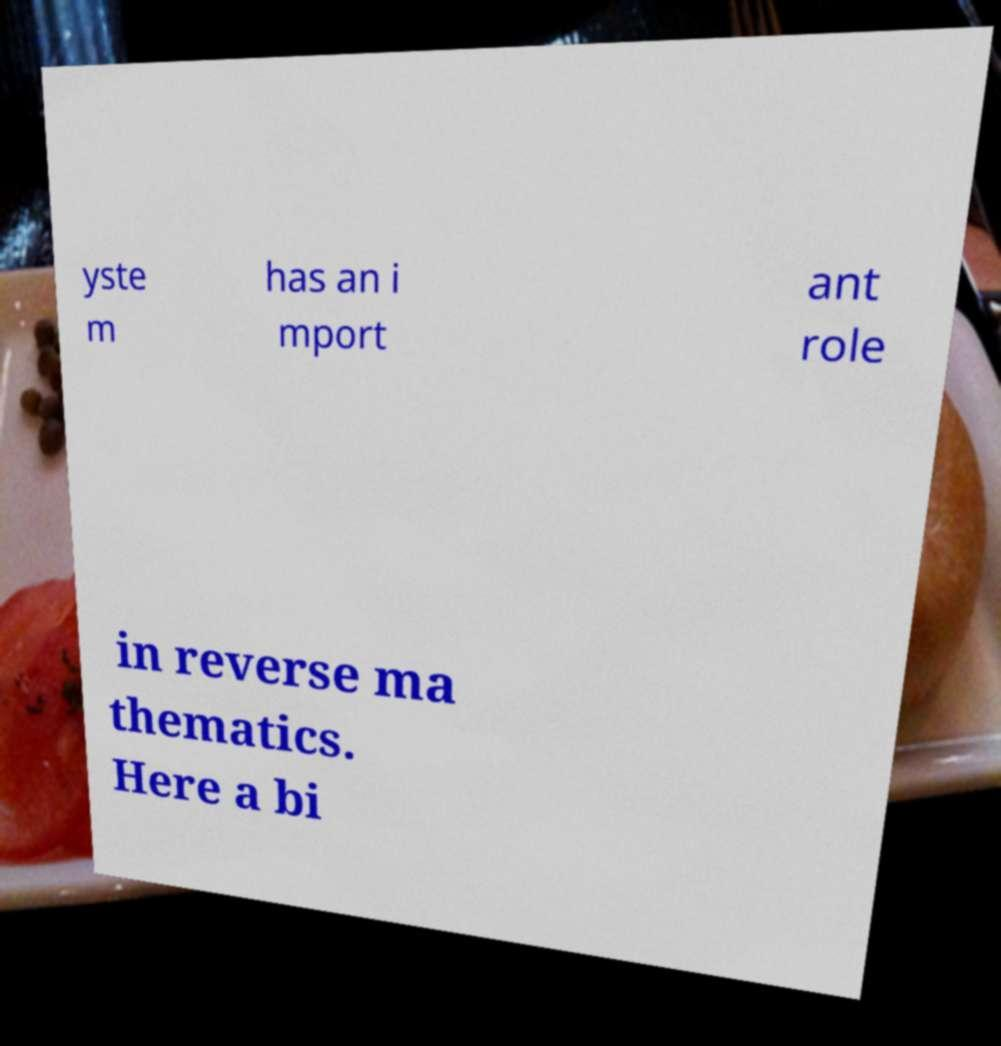Can you read and provide the text displayed in the image?This photo seems to have some interesting text. Can you extract and type it out for me? yste m has an i mport ant role in reverse ma thematics. Here a bi 